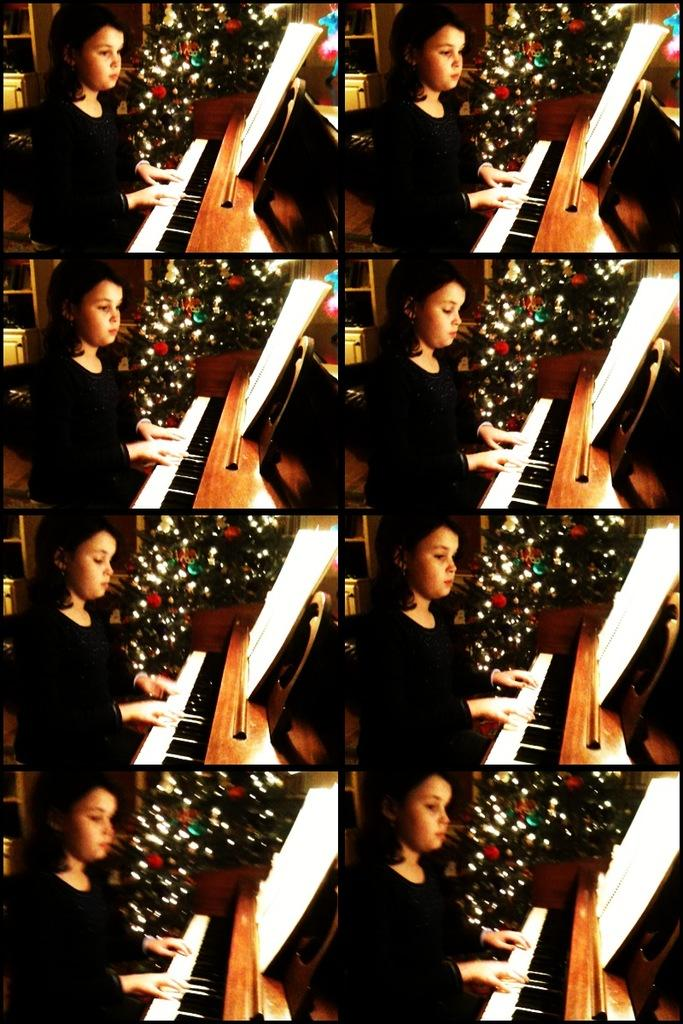Who is the main subject in the image? There is a girl in the image. What is the girl doing in the image? The girl is playing a keyboard. What can be seen in the background of the image? There is a Christmas tree in the background of the image. What is placed on the keyboard? There is a paper on the keyboard. What is used to support the keyboard? There is a stand on the keyboard. What type of lamp is hanging above the girl in the image? There is no lamp present in the image; it only features a girl playing a keyboard, a paper on the keyboard, and a stand supporting it. 